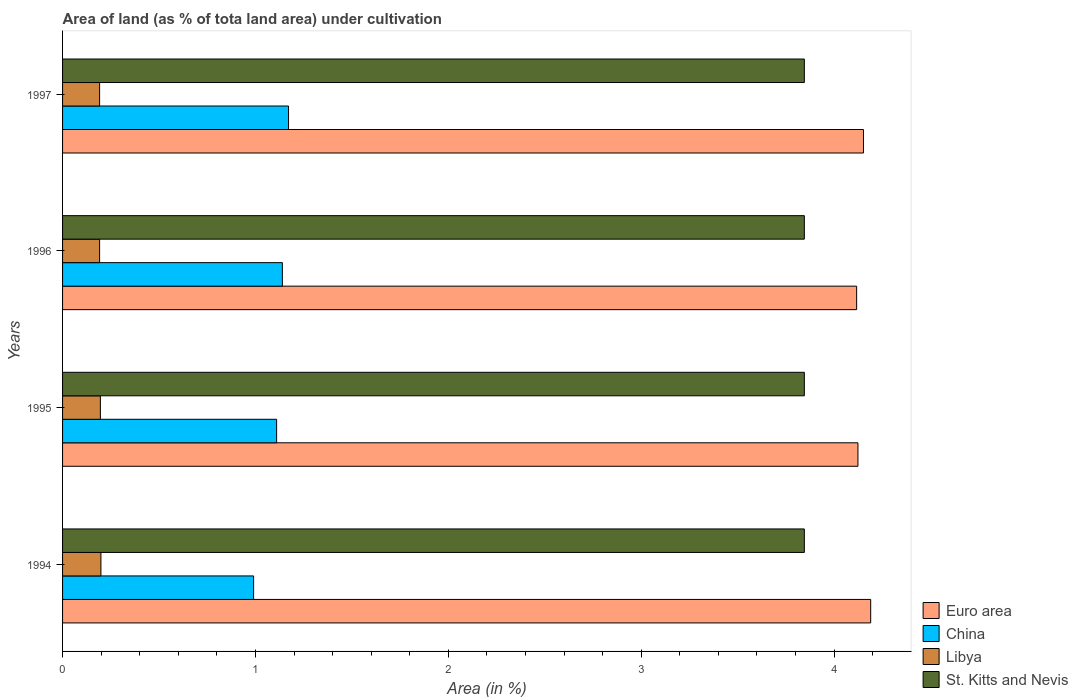How many groups of bars are there?
Offer a very short reply. 4. Are the number of bars per tick equal to the number of legend labels?
Give a very brief answer. Yes. In how many cases, is the number of bars for a given year not equal to the number of legend labels?
Ensure brevity in your answer.  0. What is the percentage of land under cultivation in Euro area in 1997?
Your response must be concise. 4.15. Across all years, what is the maximum percentage of land under cultivation in Libya?
Keep it short and to the point. 0.2. Across all years, what is the minimum percentage of land under cultivation in Libya?
Provide a short and direct response. 0.19. In which year was the percentage of land under cultivation in St. Kitts and Nevis maximum?
Provide a succinct answer. 1994. What is the total percentage of land under cultivation in China in the graph?
Give a very brief answer. 4.41. What is the difference between the percentage of land under cultivation in Libya in 1995 and that in 1996?
Your response must be concise. 0. What is the difference between the percentage of land under cultivation in Libya in 1996 and the percentage of land under cultivation in St. Kitts and Nevis in 1995?
Offer a very short reply. -3.65. What is the average percentage of land under cultivation in Libya per year?
Your answer should be very brief. 0.19. In the year 1997, what is the difference between the percentage of land under cultivation in China and percentage of land under cultivation in Euro area?
Ensure brevity in your answer.  -2.98. What is the ratio of the percentage of land under cultivation in China in 1994 to that in 1996?
Offer a terse response. 0.87. What is the difference between the highest and the second highest percentage of land under cultivation in Euro area?
Provide a succinct answer. 0.04. What is the difference between the highest and the lowest percentage of land under cultivation in China?
Offer a very short reply. 0.18. Is it the case that in every year, the sum of the percentage of land under cultivation in China and percentage of land under cultivation in Euro area is greater than the sum of percentage of land under cultivation in St. Kitts and Nevis and percentage of land under cultivation in Libya?
Your answer should be very brief. No. What does the 2nd bar from the top in 1995 represents?
Ensure brevity in your answer.  Libya. What does the 1st bar from the bottom in 1997 represents?
Give a very brief answer. Euro area. How many bars are there?
Keep it short and to the point. 16. What is the difference between two consecutive major ticks on the X-axis?
Provide a short and direct response. 1. Does the graph contain any zero values?
Make the answer very short. No. How are the legend labels stacked?
Your answer should be very brief. Vertical. What is the title of the graph?
Your answer should be compact. Area of land (as % of tota land area) under cultivation. What is the label or title of the X-axis?
Make the answer very short. Area (in %). What is the label or title of the Y-axis?
Offer a terse response. Years. What is the Area (in %) of Euro area in 1994?
Make the answer very short. 4.19. What is the Area (in %) in China in 1994?
Provide a succinct answer. 0.99. What is the Area (in %) in Libya in 1994?
Make the answer very short. 0.2. What is the Area (in %) of St. Kitts and Nevis in 1994?
Offer a terse response. 3.85. What is the Area (in %) of Euro area in 1995?
Provide a short and direct response. 4.12. What is the Area (in %) in China in 1995?
Ensure brevity in your answer.  1.11. What is the Area (in %) in Libya in 1995?
Make the answer very short. 0.2. What is the Area (in %) in St. Kitts and Nevis in 1995?
Offer a very short reply. 3.85. What is the Area (in %) in Euro area in 1996?
Your answer should be very brief. 4.12. What is the Area (in %) in China in 1996?
Make the answer very short. 1.14. What is the Area (in %) in Libya in 1996?
Offer a terse response. 0.19. What is the Area (in %) of St. Kitts and Nevis in 1996?
Keep it short and to the point. 3.85. What is the Area (in %) of Euro area in 1997?
Ensure brevity in your answer.  4.15. What is the Area (in %) in China in 1997?
Keep it short and to the point. 1.17. What is the Area (in %) in Libya in 1997?
Keep it short and to the point. 0.19. What is the Area (in %) in St. Kitts and Nevis in 1997?
Ensure brevity in your answer.  3.85. Across all years, what is the maximum Area (in %) of Euro area?
Offer a terse response. 4.19. Across all years, what is the maximum Area (in %) in China?
Ensure brevity in your answer.  1.17. Across all years, what is the maximum Area (in %) in Libya?
Provide a short and direct response. 0.2. Across all years, what is the maximum Area (in %) in St. Kitts and Nevis?
Make the answer very short. 3.85. Across all years, what is the minimum Area (in %) in Euro area?
Provide a succinct answer. 4.12. Across all years, what is the minimum Area (in %) of China?
Give a very brief answer. 0.99. Across all years, what is the minimum Area (in %) of Libya?
Provide a succinct answer. 0.19. Across all years, what is the minimum Area (in %) in St. Kitts and Nevis?
Provide a succinct answer. 3.85. What is the total Area (in %) in Euro area in the graph?
Offer a very short reply. 16.58. What is the total Area (in %) of China in the graph?
Make the answer very short. 4.41. What is the total Area (in %) in Libya in the graph?
Give a very brief answer. 0.78. What is the total Area (in %) of St. Kitts and Nevis in the graph?
Your response must be concise. 15.38. What is the difference between the Area (in %) in Euro area in 1994 and that in 1995?
Your answer should be very brief. 0.07. What is the difference between the Area (in %) of China in 1994 and that in 1995?
Your answer should be very brief. -0.12. What is the difference between the Area (in %) in Libya in 1994 and that in 1995?
Provide a succinct answer. 0. What is the difference between the Area (in %) of St. Kitts and Nevis in 1994 and that in 1995?
Make the answer very short. 0. What is the difference between the Area (in %) of Euro area in 1994 and that in 1996?
Provide a short and direct response. 0.07. What is the difference between the Area (in %) in China in 1994 and that in 1996?
Give a very brief answer. -0.15. What is the difference between the Area (in %) of Libya in 1994 and that in 1996?
Offer a very short reply. 0.01. What is the difference between the Area (in %) in Euro area in 1994 and that in 1997?
Give a very brief answer. 0.04. What is the difference between the Area (in %) in China in 1994 and that in 1997?
Provide a short and direct response. -0.18. What is the difference between the Area (in %) in Libya in 1994 and that in 1997?
Provide a succinct answer. 0.01. What is the difference between the Area (in %) of Euro area in 1995 and that in 1996?
Make the answer very short. 0.01. What is the difference between the Area (in %) of China in 1995 and that in 1996?
Offer a very short reply. -0.03. What is the difference between the Area (in %) in Libya in 1995 and that in 1996?
Keep it short and to the point. 0. What is the difference between the Area (in %) in Euro area in 1995 and that in 1997?
Give a very brief answer. -0.03. What is the difference between the Area (in %) of China in 1995 and that in 1997?
Offer a very short reply. -0.06. What is the difference between the Area (in %) of Libya in 1995 and that in 1997?
Keep it short and to the point. 0. What is the difference between the Area (in %) of Euro area in 1996 and that in 1997?
Your answer should be compact. -0.04. What is the difference between the Area (in %) in China in 1996 and that in 1997?
Give a very brief answer. -0.03. What is the difference between the Area (in %) of Euro area in 1994 and the Area (in %) of China in 1995?
Offer a terse response. 3.08. What is the difference between the Area (in %) in Euro area in 1994 and the Area (in %) in Libya in 1995?
Provide a short and direct response. 3.99. What is the difference between the Area (in %) of Euro area in 1994 and the Area (in %) of St. Kitts and Nevis in 1995?
Your answer should be compact. 0.34. What is the difference between the Area (in %) in China in 1994 and the Area (in %) in Libya in 1995?
Ensure brevity in your answer.  0.79. What is the difference between the Area (in %) in China in 1994 and the Area (in %) in St. Kitts and Nevis in 1995?
Your response must be concise. -2.86. What is the difference between the Area (in %) of Libya in 1994 and the Area (in %) of St. Kitts and Nevis in 1995?
Offer a very short reply. -3.65. What is the difference between the Area (in %) in Euro area in 1994 and the Area (in %) in China in 1996?
Ensure brevity in your answer.  3.05. What is the difference between the Area (in %) in Euro area in 1994 and the Area (in %) in Libya in 1996?
Provide a succinct answer. 4. What is the difference between the Area (in %) of Euro area in 1994 and the Area (in %) of St. Kitts and Nevis in 1996?
Give a very brief answer. 0.34. What is the difference between the Area (in %) of China in 1994 and the Area (in %) of Libya in 1996?
Give a very brief answer. 0.8. What is the difference between the Area (in %) of China in 1994 and the Area (in %) of St. Kitts and Nevis in 1996?
Your response must be concise. -2.86. What is the difference between the Area (in %) in Libya in 1994 and the Area (in %) in St. Kitts and Nevis in 1996?
Offer a terse response. -3.65. What is the difference between the Area (in %) in Euro area in 1994 and the Area (in %) in China in 1997?
Give a very brief answer. 3.02. What is the difference between the Area (in %) of Euro area in 1994 and the Area (in %) of Libya in 1997?
Offer a terse response. 4. What is the difference between the Area (in %) in Euro area in 1994 and the Area (in %) in St. Kitts and Nevis in 1997?
Offer a very short reply. 0.34. What is the difference between the Area (in %) of China in 1994 and the Area (in %) of Libya in 1997?
Your answer should be compact. 0.8. What is the difference between the Area (in %) of China in 1994 and the Area (in %) of St. Kitts and Nevis in 1997?
Keep it short and to the point. -2.86. What is the difference between the Area (in %) of Libya in 1994 and the Area (in %) of St. Kitts and Nevis in 1997?
Provide a short and direct response. -3.65. What is the difference between the Area (in %) of Euro area in 1995 and the Area (in %) of China in 1996?
Make the answer very short. 2.98. What is the difference between the Area (in %) of Euro area in 1995 and the Area (in %) of Libya in 1996?
Your response must be concise. 3.93. What is the difference between the Area (in %) of Euro area in 1995 and the Area (in %) of St. Kitts and Nevis in 1996?
Make the answer very short. 0.28. What is the difference between the Area (in %) of China in 1995 and the Area (in %) of Libya in 1996?
Provide a short and direct response. 0.92. What is the difference between the Area (in %) of China in 1995 and the Area (in %) of St. Kitts and Nevis in 1996?
Provide a succinct answer. -2.74. What is the difference between the Area (in %) of Libya in 1995 and the Area (in %) of St. Kitts and Nevis in 1996?
Offer a terse response. -3.65. What is the difference between the Area (in %) in Euro area in 1995 and the Area (in %) in China in 1997?
Give a very brief answer. 2.95. What is the difference between the Area (in %) of Euro area in 1995 and the Area (in %) of Libya in 1997?
Make the answer very short. 3.93. What is the difference between the Area (in %) of Euro area in 1995 and the Area (in %) of St. Kitts and Nevis in 1997?
Keep it short and to the point. 0.28. What is the difference between the Area (in %) in China in 1995 and the Area (in %) in Libya in 1997?
Keep it short and to the point. 0.92. What is the difference between the Area (in %) in China in 1995 and the Area (in %) in St. Kitts and Nevis in 1997?
Ensure brevity in your answer.  -2.74. What is the difference between the Area (in %) in Libya in 1995 and the Area (in %) in St. Kitts and Nevis in 1997?
Provide a succinct answer. -3.65. What is the difference between the Area (in %) in Euro area in 1996 and the Area (in %) in China in 1997?
Offer a terse response. 2.95. What is the difference between the Area (in %) of Euro area in 1996 and the Area (in %) of Libya in 1997?
Your answer should be very brief. 3.93. What is the difference between the Area (in %) of Euro area in 1996 and the Area (in %) of St. Kitts and Nevis in 1997?
Keep it short and to the point. 0.27. What is the difference between the Area (in %) of China in 1996 and the Area (in %) of Libya in 1997?
Give a very brief answer. 0.95. What is the difference between the Area (in %) of China in 1996 and the Area (in %) of St. Kitts and Nevis in 1997?
Offer a terse response. -2.71. What is the difference between the Area (in %) of Libya in 1996 and the Area (in %) of St. Kitts and Nevis in 1997?
Your answer should be very brief. -3.65. What is the average Area (in %) of Euro area per year?
Your answer should be very brief. 4.15. What is the average Area (in %) in China per year?
Make the answer very short. 1.1. What is the average Area (in %) in Libya per year?
Make the answer very short. 0.19. What is the average Area (in %) in St. Kitts and Nevis per year?
Ensure brevity in your answer.  3.85. In the year 1994, what is the difference between the Area (in %) of Euro area and Area (in %) of China?
Provide a short and direct response. 3.2. In the year 1994, what is the difference between the Area (in %) in Euro area and Area (in %) in Libya?
Offer a very short reply. 3.99. In the year 1994, what is the difference between the Area (in %) in Euro area and Area (in %) in St. Kitts and Nevis?
Provide a succinct answer. 0.34. In the year 1994, what is the difference between the Area (in %) of China and Area (in %) of Libya?
Offer a terse response. 0.79. In the year 1994, what is the difference between the Area (in %) of China and Area (in %) of St. Kitts and Nevis?
Your answer should be very brief. -2.86. In the year 1994, what is the difference between the Area (in %) of Libya and Area (in %) of St. Kitts and Nevis?
Your response must be concise. -3.65. In the year 1995, what is the difference between the Area (in %) of Euro area and Area (in %) of China?
Your answer should be very brief. 3.01. In the year 1995, what is the difference between the Area (in %) in Euro area and Area (in %) in Libya?
Ensure brevity in your answer.  3.93. In the year 1995, what is the difference between the Area (in %) in Euro area and Area (in %) in St. Kitts and Nevis?
Offer a terse response. 0.28. In the year 1995, what is the difference between the Area (in %) in China and Area (in %) in Libya?
Keep it short and to the point. 0.91. In the year 1995, what is the difference between the Area (in %) of China and Area (in %) of St. Kitts and Nevis?
Your response must be concise. -2.74. In the year 1995, what is the difference between the Area (in %) of Libya and Area (in %) of St. Kitts and Nevis?
Your response must be concise. -3.65. In the year 1996, what is the difference between the Area (in %) of Euro area and Area (in %) of China?
Your answer should be very brief. 2.98. In the year 1996, what is the difference between the Area (in %) in Euro area and Area (in %) in Libya?
Keep it short and to the point. 3.93. In the year 1996, what is the difference between the Area (in %) of Euro area and Area (in %) of St. Kitts and Nevis?
Your answer should be compact. 0.27. In the year 1996, what is the difference between the Area (in %) of China and Area (in %) of Libya?
Your answer should be compact. 0.95. In the year 1996, what is the difference between the Area (in %) of China and Area (in %) of St. Kitts and Nevis?
Provide a succinct answer. -2.71. In the year 1996, what is the difference between the Area (in %) in Libya and Area (in %) in St. Kitts and Nevis?
Provide a succinct answer. -3.65. In the year 1997, what is the difference between the Area (in %) in Euro area and Area (in %) in China?
Keep it short and to the point. 2.98. In the year 1997, what is the difference between the Area (in %) in Euro area and Area (in %) in Libya?
Your response must be concise. 3.96. In the year 1997, what is the difference between the Area (in %) in Euro area and Area (in %) in St. Kitts and Nevis?
Ensure brevity in your answer.  0.31. In the year 1997, what is the difference between the Area (in %) in China and Area (in %) in Libya?
Your response must be concise. 0.98. In the year 1997, what is the difference between the Area (in %) in China and Area (in %) in St. Kitts and Nevis?
Your answer should be compact. -2.67. In the year 1997, what is the difference between the Area (in %) of Libya and Area (in %) of St. Kitts and Nevis?
Provide a short and direct response. -3.65. What is the ratio of the Area (in %) of China in 1994 to that in 1995?
Make the answer very short. 0.89. What is the ratio of the Area (in %) of Libya in 1994 to that in 1995?
Make the answer very short. 1.01. What is the ratio of the Area (in %) of St. Kitts and Nevis in 1994 to that in 1995?
Provide a succinct answer. 1. What is the ratio of the Area (in %) of Euro area in 1994 to that in 1996?
Offer a terse response. 1.02. What is the ratio of the Area (in %) in China in 1994 to that in 1996?
Offer a very short reply. 0.87. What is the ratio of the Area (in %) in Libya in 1994 to that in 1996?
Provide a short and direct response. 1.04. What is the ratio of the Area (in %) in St. Kitts and Nevis in 1994 to that in 1996?
Offer a terse response. 1. What is the ratio of the Area (in %) of China in 1994 to that in 1997?
Keep it short and to the point. 0.85. What is the ratio of the Area (in %) of Libya in 1994 to that in 1997?
Keep it short and to the point. 1.04. What is the ratio of the Area (in %) of St. Kitts and Nevis in 1994 to that in 1997?
Keep it short and to the point. 1. What is the ratio of the Area (in %) in China in 1995 to that in 1996?
Your answer should be very brief. 0.97. What is the ratio of the Area (in %) in Libya in 1995 to that in 1996?
Your response must be concise. 1.02. What is the ratio of the Area (in %) in St. Kitts and Nevis in 1995 to that in 1996?
Provide a succinct answer. 1. What is the ratio of the Area (in %) in China in 1995 to that in 1997?
Your response must be concise. 0.95. What is the ratio of the Area (in %) in Libya in 1995 to that in 1997?
Ensure brevity in your answer.  1.02. What is the ratio of the Area (in %) of St. Kitts and Nevis in 1995 to that in 1997?
Make the answer very short. 1. What is the ratio of the Area (in %) in China in 1996 to that in 1997?
Offer a terse response. 0.97. What is the ratio of the Area (in %) of Libya in 1996 to that in 1997?
Provide a succinct answer. 1. What is the ratio of the Area (in %) of St. Kitts and Nevis in 1996 to that in 1997?
Give a very brief answer. 1. What is the difference between the highest and the second highest Area (in %) in Euro area?
Provide a short and direct response. 0.04. What is the difference between the highest and the second highest Area (in %) in China?
Keep it short and to the point. 0.03. What is the difference between the highest and the second highest Area (in %) in Libya?
Your answer should be compact. 0. What is the difference between the highest and the second highest Area (in %) of St. Kitts and Nevis?
Offer a terse response. 0. What is the difference between the highest and the lowest Area (in %) of Euro area?
Your response must be concise. 0.07. What is the difference between the highest and the lowest Area (in %) of China?
Provide a short and direct response. 0.18. What is the difference between the highest and the lowest Area (in %) in Libya?
Your answer should be compact. 0.01. 